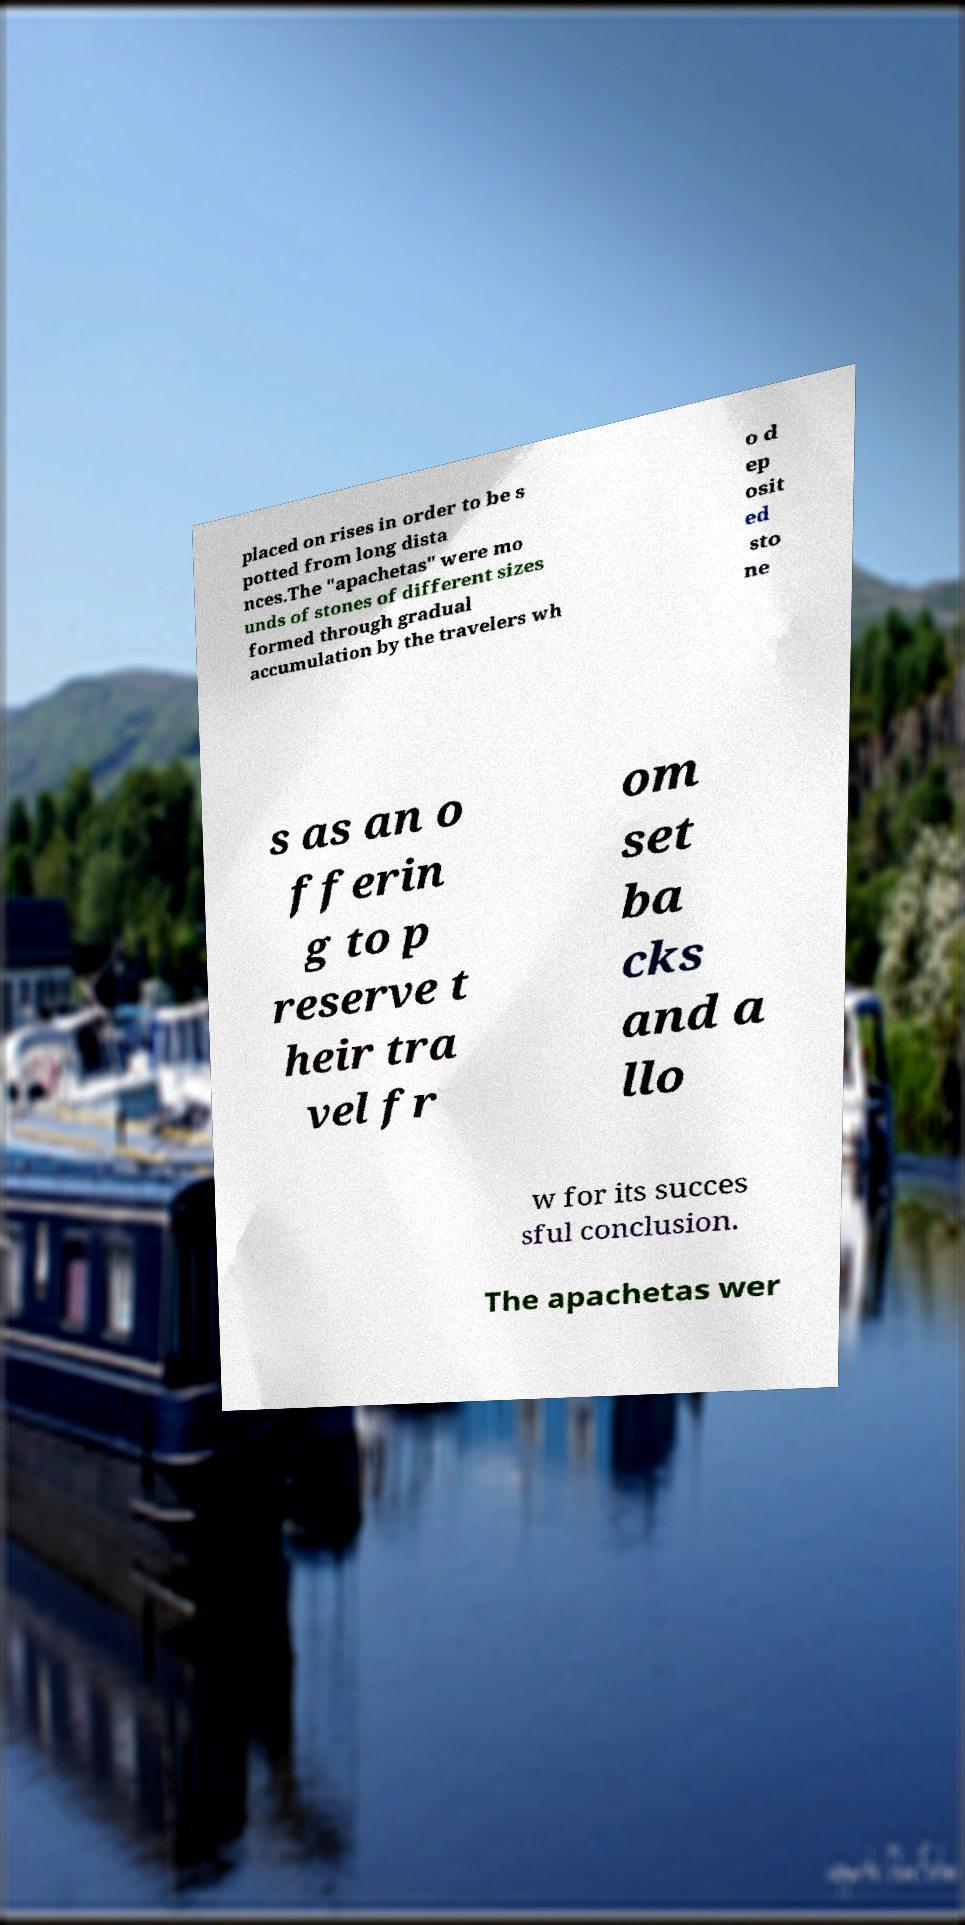Can you read and provide the text displayed in the image?This photo seems to have some interesting text. Can you extract and type it out for me? placed on rises in order to be s potted from long dista nces.The "apachetas" were mo unds of stones of different sizes formed through gradual accumulation by the travelers wh o d ep osit ed sto ne s as an o fferin g to p reserve t heir tra vel fr om set ba cks and a llo w for its succes sful conclusion. The apachetas wer 